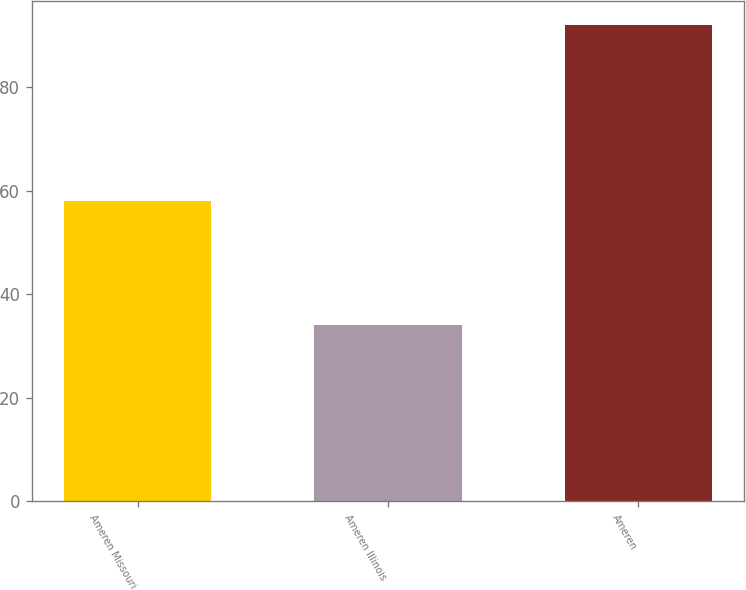Convert chart to OTSL. <chart><loc_0><loc_0><loc_500><loc_500><bar_chart><fcel>Ameren Missouri<fcel>Ameren Illinois<fcel>Ameren<nl><fcel>58<fcel>34<fcel>92<nl></chart> 